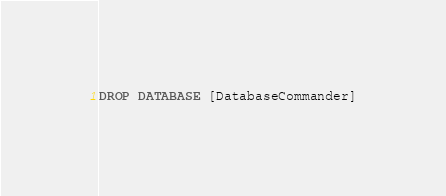Convert code to text. <code><loc_0><loc_0><loc_500><loc_500><_SQL_>DROP DATABASE [DatabaseCommander]</code> 